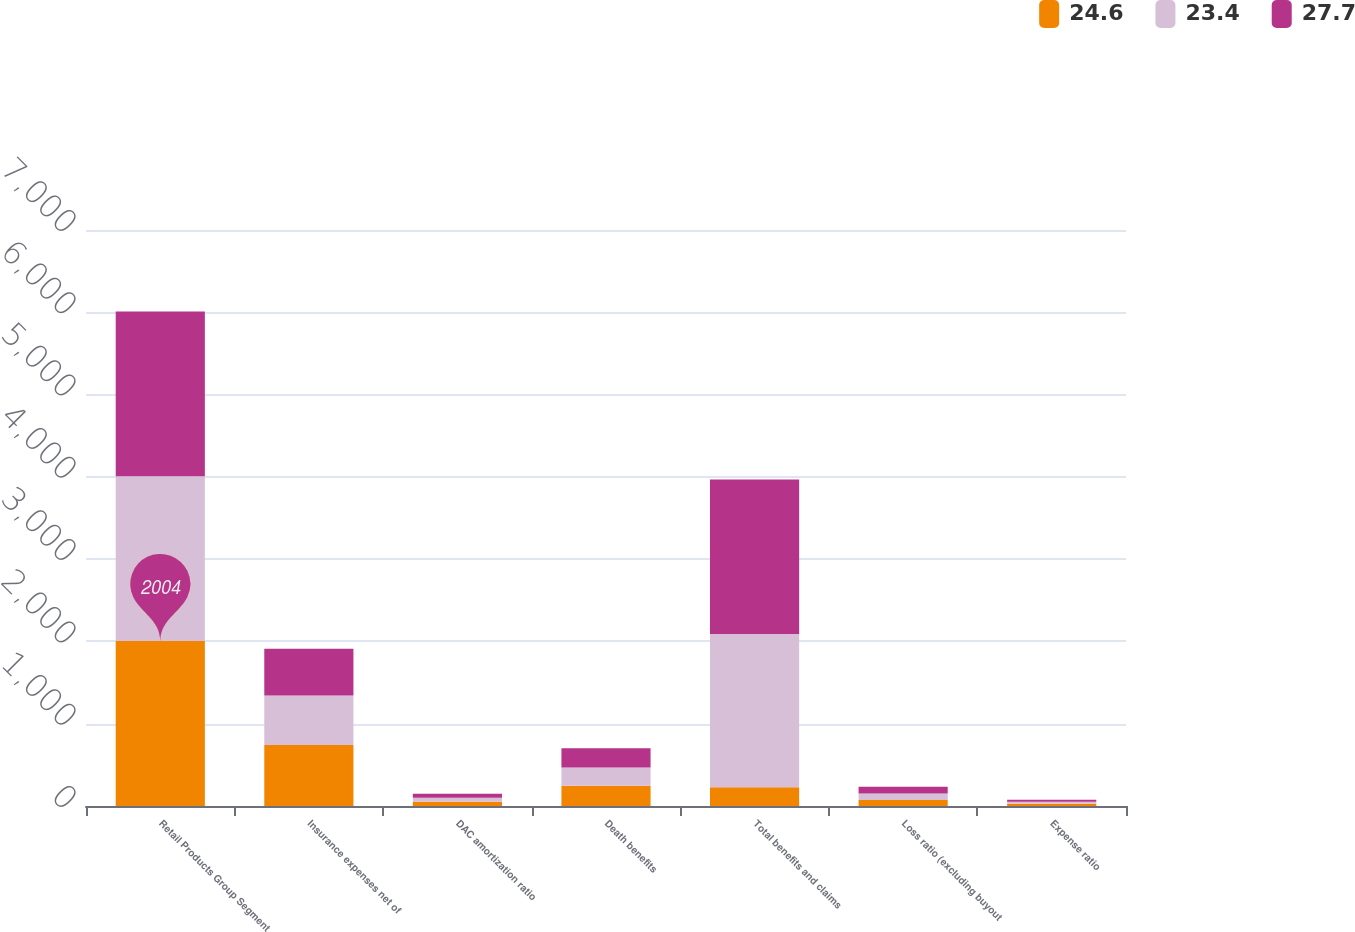Convert chart. <chart><loc_0><loc_0><loc_500><loc_500><stacked_bar_chart><ecel><fcel>Retail Products Group Segment<fcel>Insurance expenses net of<fcel>DAC amortization ratio<fcel>Death benefits<fcel>Total benefits and claims<fcel>Loss ratio (excluding buyout<fcel>Expense ratio<nl><fcel>24.6<fcel>2004<fcel>742<fcel>50.8<fcel>245<fcel>228<fcel>74<fcel>27.7<nl><fcel>23.4<fcel>2003<fcel>602<fcel>49.6<fcel>224<fcel>1862<fcel>78.5<fcel>24.6<nl><fcel>27.7<fcel>2002<fcel>568<fcel>47<fcel>232<fcel>1878<fcel>80.6<fcel>23.4<nl></chart> 